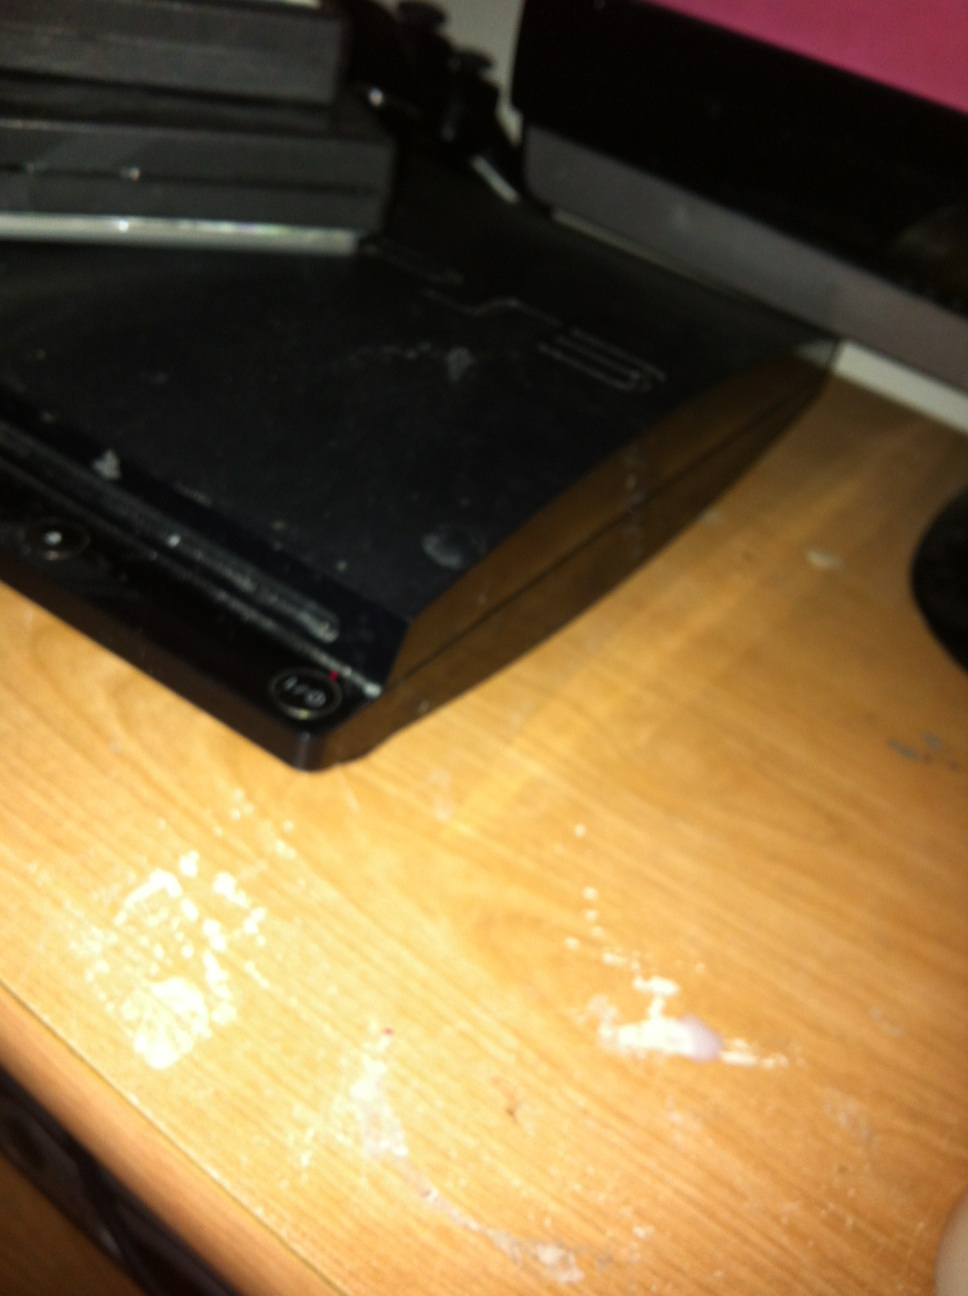Describe a scenario of a gamer playing a favorite game on this PlayStation 3 A gamer sits down in their cozy living room on a Friday evening, ready to unwind after a long week. The room is softly lit, the glow of the television screen casting a warm light. They power on their PlayStation 3, and the familiar startup chime brings a sense of nostalgia and excitement. Today, they’ve decided to dive back into one of their all-time favorite games, 'Uncharted 2: Among Thieves'. As the game loads, they’re instantly transported into the lush, detailed jungles of Borneo, guiding the protagonist, Nathan Drake, through treacherous ruins and intense firefights. The gamer’s heart races as they navigate daring cliffside jumps and solve ancient puzzles. They’re fully immersed, shouting in triumph and gasping in suspense. Time flies by as they get lost in the captivating story and breathtaking visuals, the PlayStation 3 proving once again why it holds a special place in their gaming collection. 